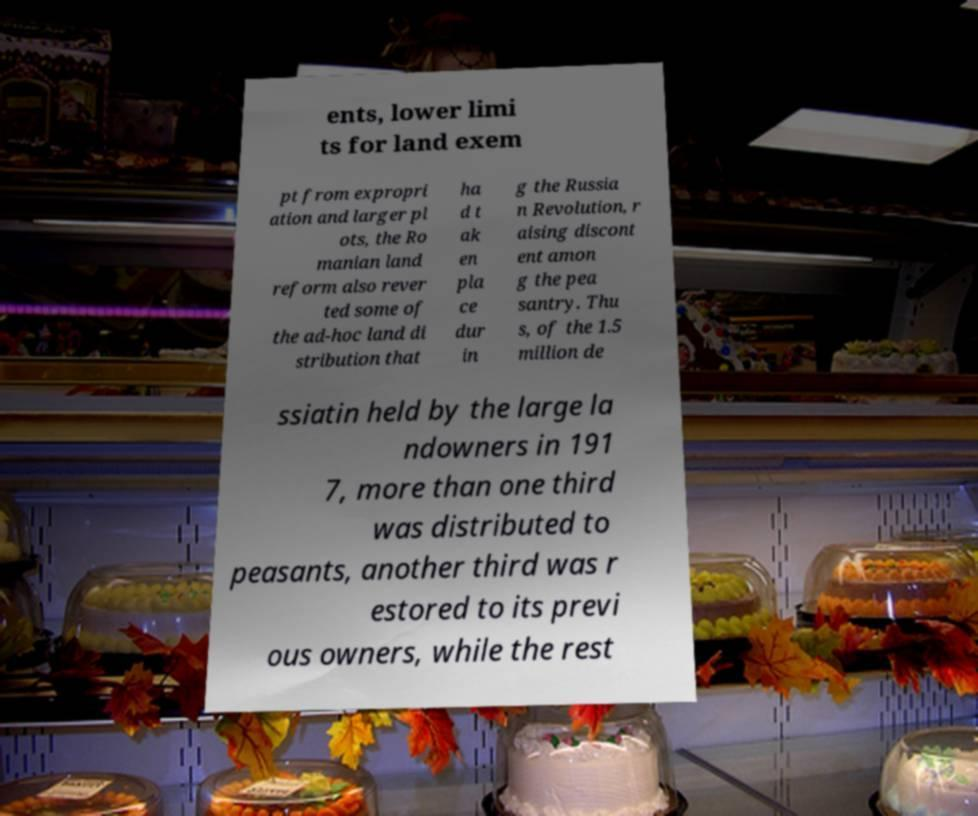Can you read and provide the text displayed in the image?This photo seems to have some interesting text. Can you extract and type it out for me? ents, lower limi ts for land exem pt from expropri ation and larger pl ots, the Ro manian land reform also rever ted some of the ad-hoc land di stribution that ha d t ak en pla ce dur in g the Russia n Revolution, r aising discont ent amon g the pea santry. Thu s, of the 1.5 million de ssiatin held by the large la ndowners in 191 7, more than one third was distributed to peasants, another third was r estored to its previ ous owners, while the rest 